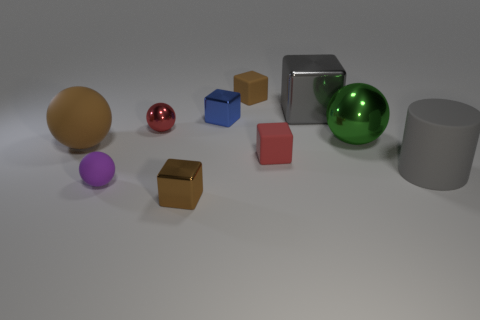How many metal things are either big cylinders or tiny red balls? In the image provided, there is one large metal cylinder, identifiable by its reflective silver surface, and there are no tiny red balls present. Therefore, the total count of metal things that are either big cylinders or tiny red balls is one. 